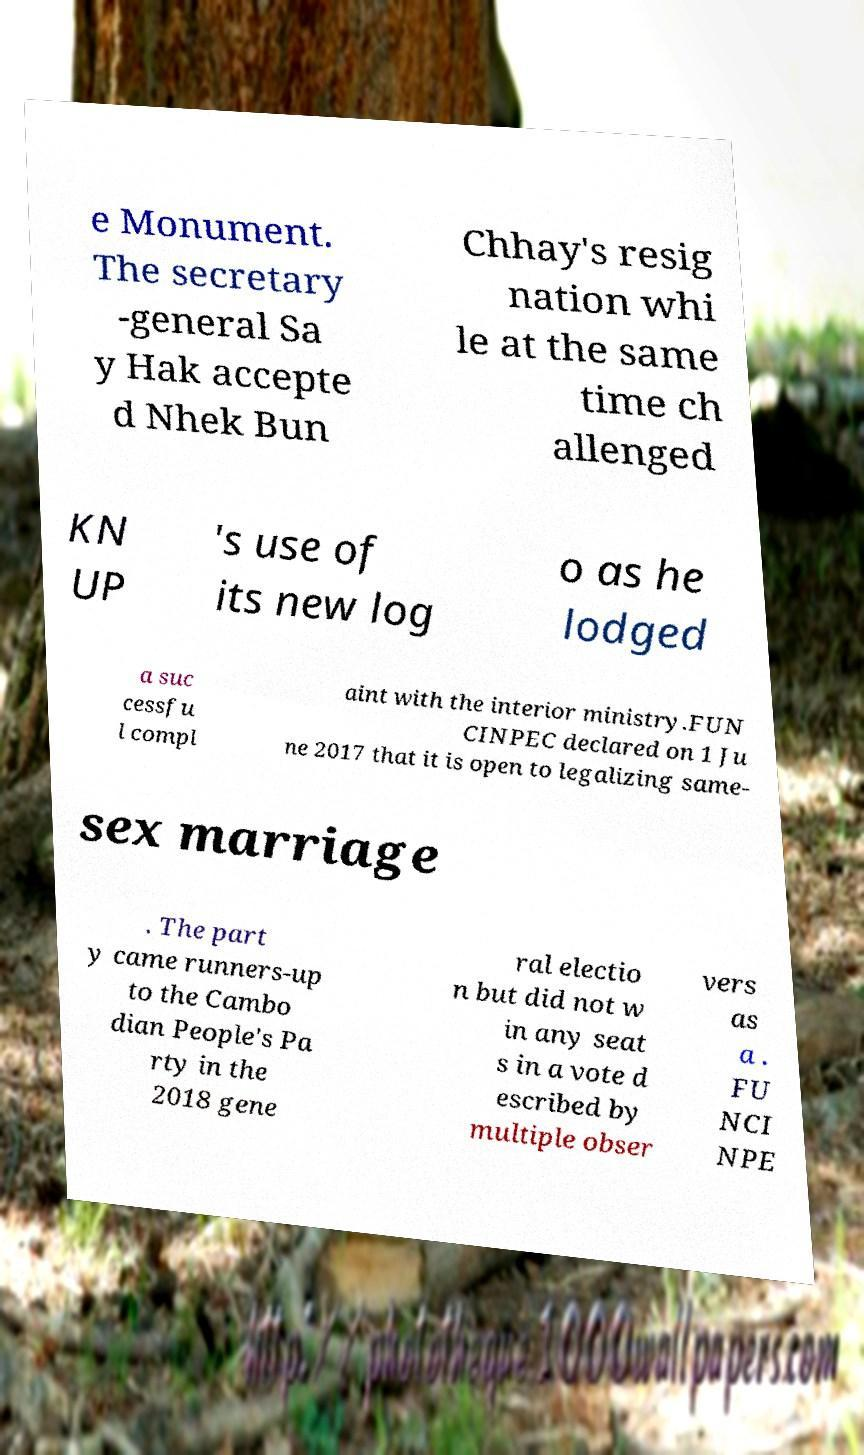Please identify and transcribe the text found in this image. e Monument. The secretary -general Sa y Hak accepte d Nhek Bun Chhay's resig nation whi le at the same time ch allenged KN UP 's use of its new log o as he lodged a suc cessfu l compl aint with the interior ministry.FUN CINPEC declared on 1 Ju ne 2017 that it is open to legalizing same- sex marriage . The part y came runners-up to the Cambo dian People's Pa rty in the 2018 gene ral electio n but did not w in any seat s in a vote d escribed by multiple obser vers as a . FU NCI NPE 